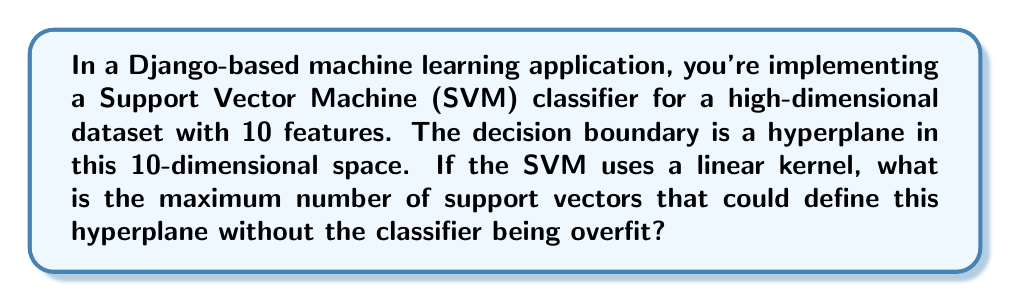Teach me how to tackle this problem. To answer this question, we need to understand the geometric properties of SVM decision boundaries in high-dimensional spaces:

1. In an SVM with a linear kernel, the decision boundary is a hyperplane.

2. In an n-dimensional space, a hyperplane is defined by n points that are not linearly dependent.

3. Our feature space has 10 dimensions, so n = 10.

4. The maximum number of support vectors that can define the hyperplane without overfitting is equal to n + 1.

5. This is because:
   a. n points are needed to uniquely define the hyperplane.
   b. One additional point can be used to determine the margin.
   c. Any more points would lead to overfitting, as they would unnecessarily constrain the hyperplane.

6. Therefore, the maximum number of support vectors is:

   $$10 + 1 = 11$$

This result is important for a data scientist working with Django and machine learning, as it helps in understanding the complexity and potential overfitting of the SVM model in high-dimensional spaces.
Answer: 11 